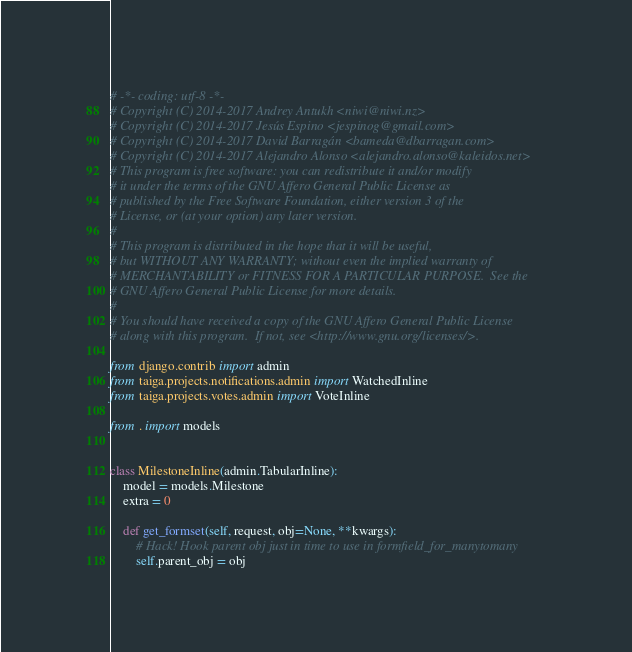<code> <loc_0><loc_0><loc_500><loc_500><_Python_># -*- coding: utf-8 -*-
# Copyright (C) 2014-2017 Andrey Antukh <niwi@niwi.nz>
# Copyright (C) 2014-2017 Jesús Espino <jespinog@gmail.com>
# Copyright (C) 2014-2017 David Barragán <bameda@dbarragan.com>
# Copyright (C) 2014-2017 Alejandro Alonso <alejandro.alonso@kaleidos.net>
# This program is free software: you can redistribute it and/or modify
# it under the terms of the GNU Affero General Public License as
# published by the Free Software Foundation, either version 3 of the
# License, or (at your option) any later version.
#
# This program is distributed in the hope that it will be useful,
# but WITHOUT ANY WARRANTY; without even the implied warranty of
# MERCHANTABILITY or FITNESS FOR A PARTICULAR PURPOSE.  See the
# GNU Affero General Public License for more details.
#
# You should have received a copy of the GNU Affero General Public License
# along with this program.  If not, see <http://www.gnu.org/licenses/>.

from django.contrib import admin
from taiga.projects.notifications.admin import WatchedInline
from taiga.projects.votes.admin import VoteInline

from . import models


class MilestoneInline(admin.TabularInline):
    model = models.Milestone
    extra = 0

    def get_formset(self, request, obj=None, **kwargs):
        # Hack! Hook parent obj just in time to use in formfield_for_manytomany
        self.parent_obj = obj</code> 